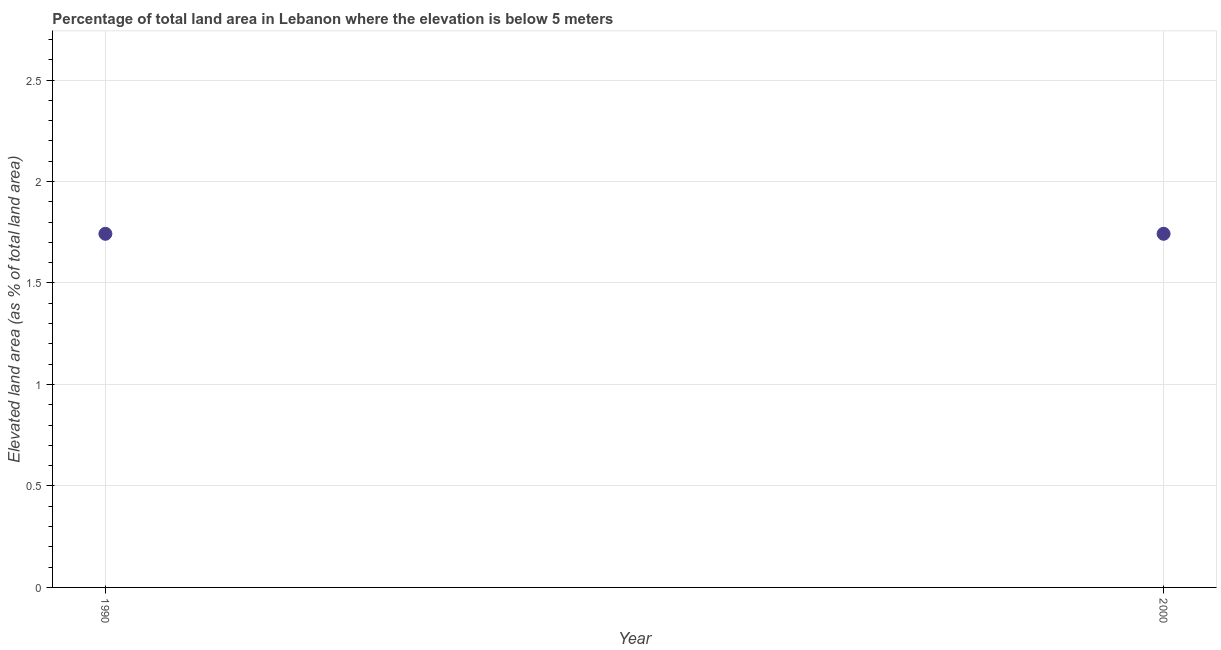What is the total elevated land area in 2000?
Your answer should be very brief. 1.74. Across all years, what is the maximum total elevated land area?
Provide a succinct answer. 1.74. Across all years, what is the minimum total elevated land area?
Offer a terse response. 1.74. In which year was the total elevated land area maximum?
Offer a very short reply. 1990. What is the sum of the total elevated land area?
Offer a very short reply. 3.48. What is the difference between the total elevated land area in 1990 and 2000?
Keep it short and to the point. 0. What is the average total elevated land area per year?
Make the answer very short. 1.74. What is the median total elevated land area?
Offer a very short reply. 1.74. In how many years, is the total elevated land area greater than 2.5 %?
Your response must be concise. 0. What is the ratio of the total elevated land area in 1990 to that in 2000?
Give a very brief answer. 1. In how many years, is the total elevated land area greater than the average total elevated land area taken over all years?
Your response must be concise. 0. Does the total elevated land area monotonically increase over the years?
Provide a short and direct response. No. What is the title of the graph?
Your response must be concise. Percentage of total land area in Lebanon where the elevation is below 5 meters. What is the label or title of the Y-axis?
Your answer should be very brief. Elevated land area (as % of total land area). What is the Elevated land area (as % of total land area) in 1990?
Give a very brief answer. 1.74. What is the Elevated land area (as % of total land area) in 2000?
Your answer should be very brief. 1.74. What is the ratio of the Elevated land area (as % of total land area) in 1990 to that in 2000?
Offer a very short reply. 1. 